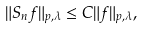Convert formula to latex. <formula><loc_0><loc_0><loc_500><loc_500>\| S _ { n } f \| _ { p , \lambda } \leq C \| f \| _ { p , \lambda } ,</formula> 